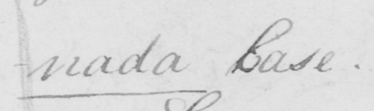What does this handwritten line say? -nada Base . 